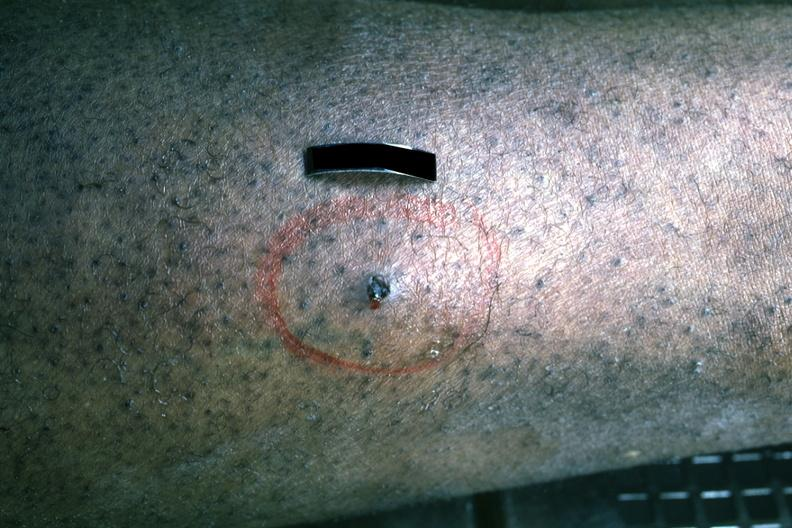where is this?
Answer the question using a single word or phrase. Skin 